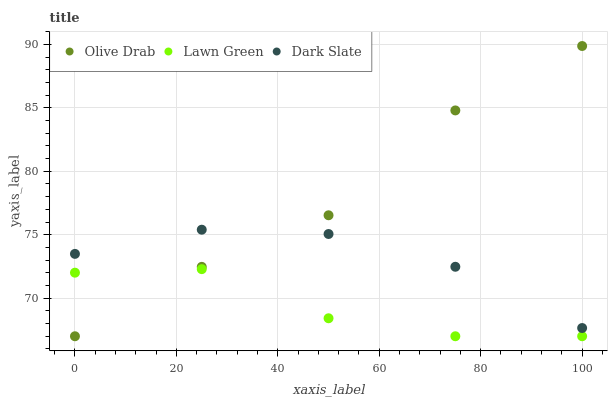Does Lawn Green have the minimum area under the curve?
Answer yes or no. Yes. Does Olive Drab have the maximum area under the curve?
Answer yes or no. Yes. Does Dark Slate have the minimum area under the curve?
Answer yes or no. No. Does Dark Slate have the maximum area under the curve?
Answer yes or no. No. Is Dark Slate the smoothest?
Answer yes or no. Yes. Is Olive Drab the roughest?
Answer yes or no. Yes. Is Olive Drab the smoothest?
Answer yes or no. No. Is Dark Slate the roughest?
Answer yes or no. No. Does Lawn Green have the lowest value?
Answer yes or no. Yes. Does Dark Slate have the lowest value?
Answer yes or no. No. Does Olive Drab have the highest value?
Answer yes or no. Yes. Does Dark Slate have the highest value?
Answer yes or no. No. Is Lawn Green less than Dark Slate?
Answer yes or no. Yes. Is Dark Slate greater than Lawn Green?
Answer yes or no. Yes. Does Lawn Green intersect Olive Drab?
Answer yes or no. Yes. Is Lawn Green less than Olive Drab?
Answer yes or no. No. Is Lawn Green greater than Olive Drab?
Answer yes or no. No. Does Lawn Green intersect Dark Slate?
Answer yes or no. No. 